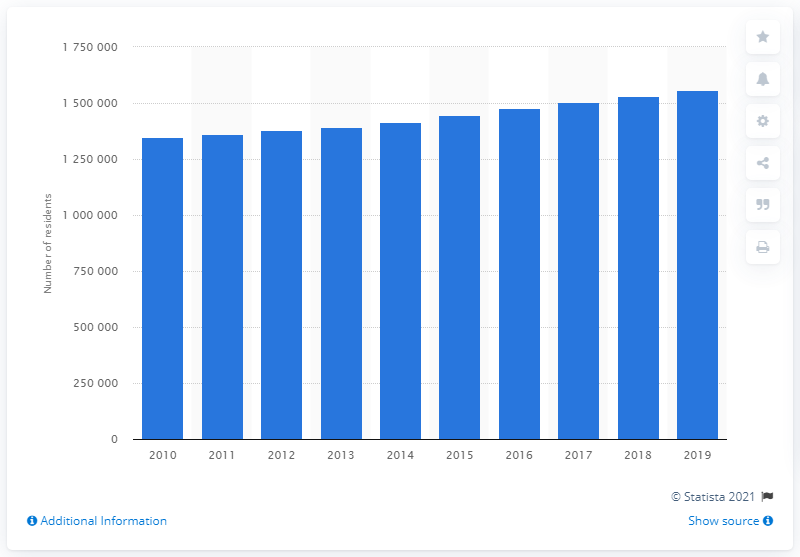Highlight a few significant elements in this photo. In the year 2019, it is estimated that a total of 155,9514 people resided within the Jacksonville metropolitan area. 